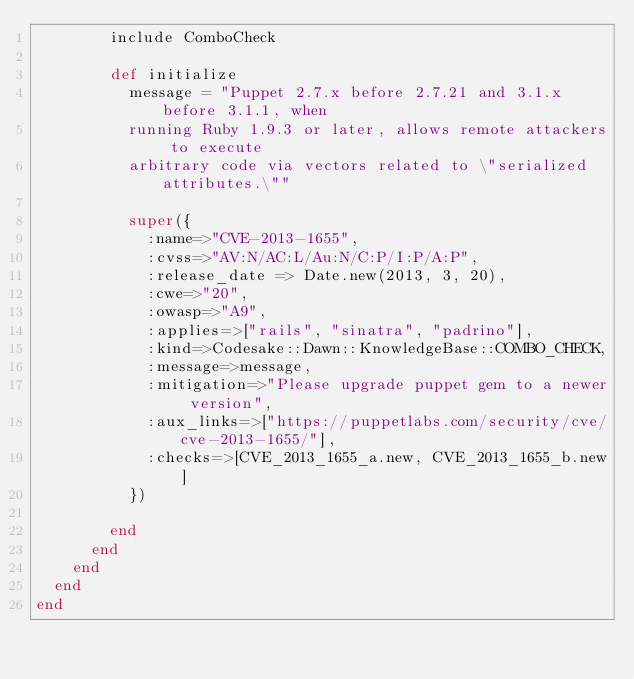<code> <loc_0><loc_0><loc_500><loc_500><_Ruby_>        include ComboCheck

        def initialize
          message = "Puppet 2.7.x before 2.7.21 and 3.1.x before 3.1.1, when
          running Ruby 1.9.3 or later, allows remote attackers to execute
          arbitrary code via vectors related to \"serialized attributes.\""

          super({
            :name=>"CVE-2013-1655",
            :cvss=>"AV:N/AC:L/Au:N/C:P/I:P/A:P",
            :release_date => Date.new(2013, 3, 20),
            :cwe=>"20",
            :owasp=>"A9", 
            :applies=>["rails", "sinatra", "padrino"],
            :kind=>Codesake::Dawn::KnowledgeBase::COMBO_CHECK,
            :message=>message,
            :mitigation=>"Please upgrade puppet gem to a newer version",
            :aux_links=>["https://puppetlabs.com/security/cve/cve-2013-1655/"],
            :checks=>[CVE_2013_1655_a.new, CVE_2013_1655_b.new]
          })

        end
      end
    end
  end
end
</code> 